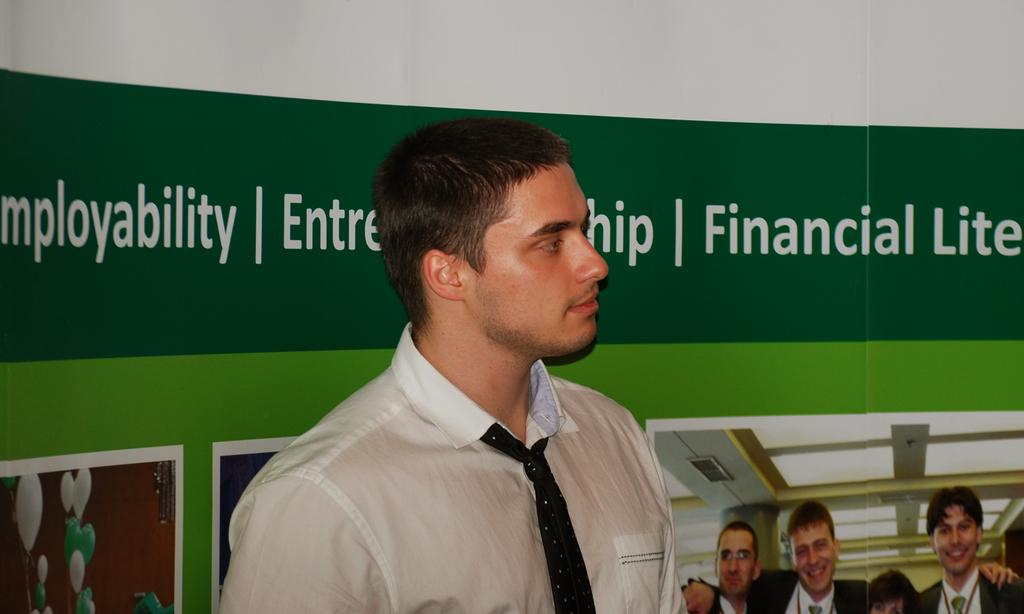What is the main subject of the image? There is a person standing in the image. What is the person wearing around their neck? The person is wearing a tie. What color is the shirt the person is wearing? The person is wearing a white shirt. What can be seen on the wall behind the person? There is a banner on the wall behind the person. What type of farm animals can be seen in the aftermath of the image? There is no farm or aftermath present in the image; it features a person standing with a tie and white shirt, and a banner on the wall. 